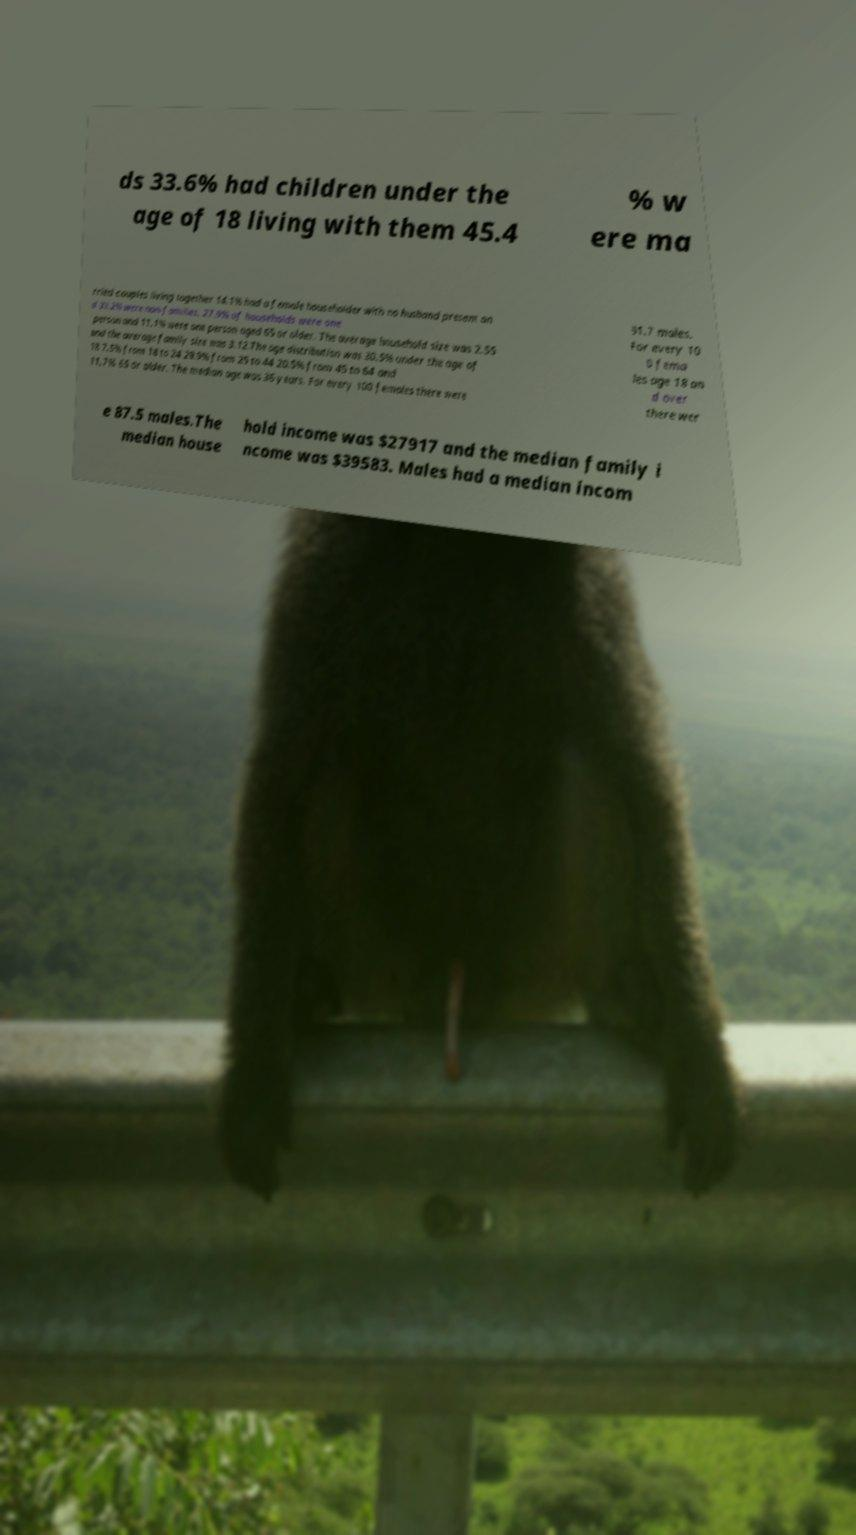I need the written content from this picture converted into text. Can you do that? ds 33.6% had children under the age of 18 living with them 45.4 % w ere ma rried couples living together 14.1% had a female householder with no husband present an d 33.2% were non-families. 27.9% of households were one person and 11.1% were one person aged 65 or older. The average household size was 2.55 and the average family size was 3.12.The age distribution was 30.5% under the age of 18 7.5% from 18 to 24 29.9% from 25 to 44 20.5% from 45 to 64 and 11.7% 65 or older. The median age was 36 years. For every 100 females there were 91.7 males. For every 10 0 fema les age 18 an d over there wer e 87.5 males.The median house hold income was $27917 and the median family i ncome was $39583. Males had a median incom 